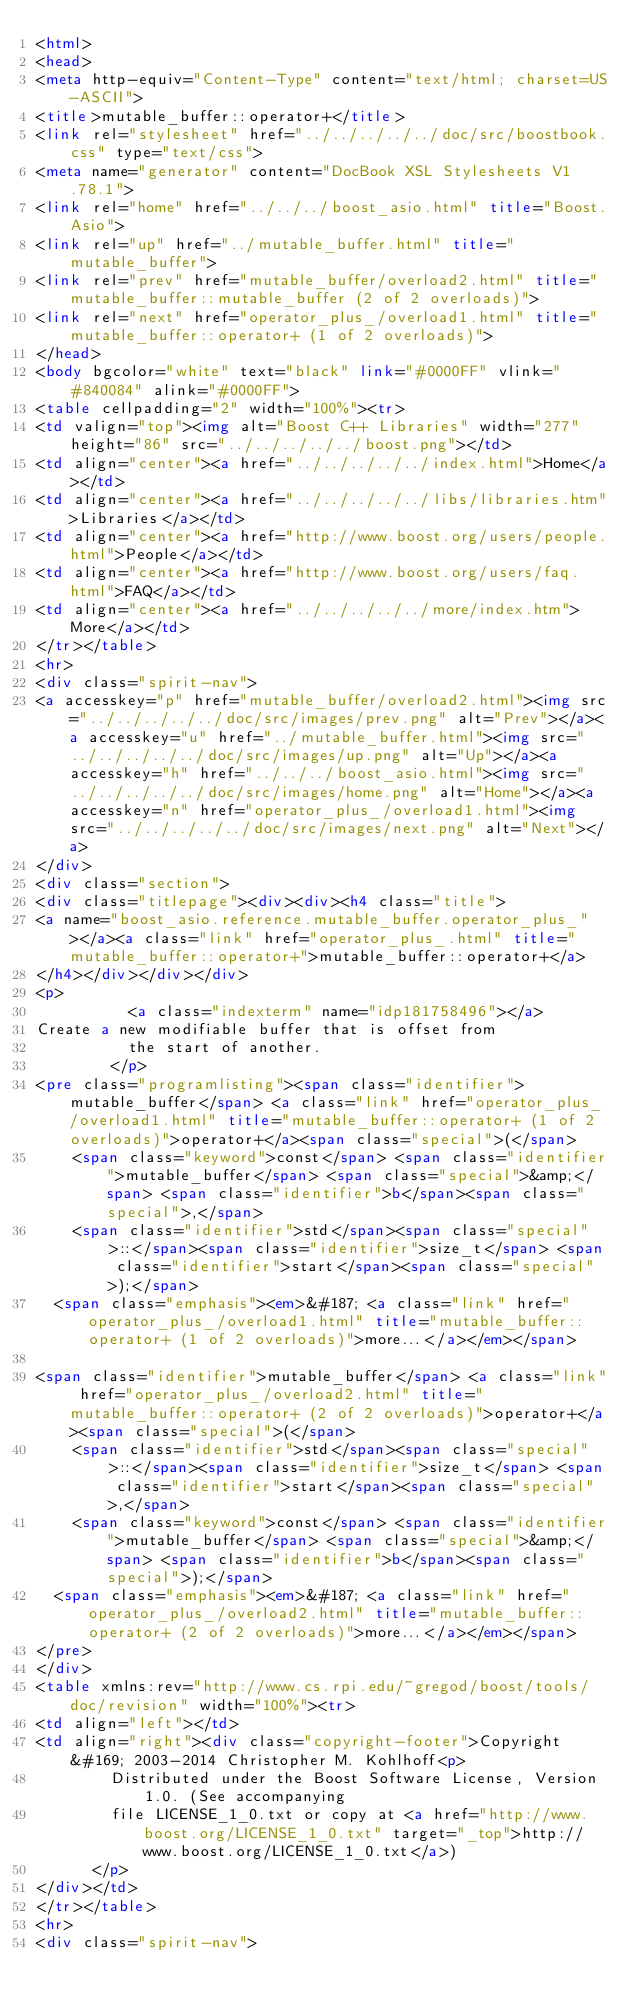Convert code to text. <code><loc_0><loc_0><loc_500><loc_500><_HTML_><html>
<head>
<meta http-equiv="Content-Type" content="text/html; charset=US-ASCII">
<title>mutable_buffer::operator+</title>
<link rel="stylesheet" href="../../../../../doc/src/boostbook.css" type="text/css">
<meta name="generator" content="DocBook XSL Stylesheets V1.78.1">
<link rel="home" href="../../../boost_asio.html" title="Boost.Asio">
<link rel="up" href="../mutable_buffer.html" title="mutable_buffer">
<link rel="prev" href="mutable_buffer/overload2.html" title="mutable_buffer::mutable_buffer (2 of 2 overloads)">
<link rel="next" href="operator_plus_/overload1.html" title="mutable_buffer::operator+ (1 of 2 overloads)">
</head>
<body bgcolor="white" text="black" link="#0000FF" vlink="#840084" alink="#0000FF">
<table cellpadding="2" width="100%"><tr>
<td valign="top"><img alt="Boost C++ Libraries" width="277" height="86" src="../../../../../boost.png"></td>
<td align="center"><a href="../../../../../index.html">Home</a></td>
<td align="center"><a href="../../../../../libs/libraries.htm">Libraries</a></td>
<td align="center"><a href="http://www.boost.org/users/people.html">People</a></td>
<td align="center"><a href="http://www.boost.org/users/faq.html">FAQ</a></td>
<td align="center"><a href="../../../../../more/index.htm">More</a></td>
</tr></table>
<hr>
<div class="spirit-nav">
<a accesskey="p" href="mutable_buffer/overload2.html"><img src="../../../../../doc/src/images/prev.png" alt="Prev"></a><a accesskey="u" href="../mutable_buffer.html"><img src="../../../../../doc/src/images/up.png" alt="Up"></a><a accesskey="h" href="../../../boost_asio.html"><img src="../../../../../doc/src/images/home.png" alt="Home"></a><a accesskey="n" href="operator_plus_/overload1.html"><img src="../../../../../doc/src/images/next.png" alt="Next"></a>
</div>
<div class="section">
<div class="titlepage"><div><div><h4 class="title">
<a name="boost_asio.reference.mutable_buffer.operator_plus_"></a><a class="link" href="operator_plus_.html" title="mutable_buffer::operator+">mutable_buffer::operator+</a>
</h4></div></div></div>
<p>
          <a class="indexterm" name="idp181758496"></a> 
Create a new modifiable buffer that is offset from
          the start of another.
        </p>
<pre class="programlisting"><span class="identifier">mutable_buffer</span> <a class="link" href="operator_plus_/overload1.html" title="mutable_buffer::operator+ (1 of 2 overloads)">operator+</a><span class="special">(</span>
    <span class="keyword">const</span> <span class="identifier">mutable_buffer</span> <span class="special">&amp;</span> <span class="identifier">b</span><span class="special">,</span>
    <span class="identifier">std</span><span class="special">::</span><span class="identifier">size_t</span> <span class="identifier">start</span><span class="special">);</span>
  <span class="emphasis"><em>&#187; <a class="link" href="operator_plus_/overload1.html" title="mutable_buffer::operator+ (1 of 2 overloads)">more...</a></em></span>

<span class="identifier">mutable_buffer</span> <a class="link" href="operator_plus_/overload2.html" title="mutable_buffer::operator+ (2 of 2 overloads)">operator+</a><span class="special">(</span>
    <span class="identifier">std</span><span class="special">::</span><span class="identifier">size_t</span> <span class="identifier">start</span><span class="special">,</span>
    <span class="keyword">const</span> <span class="identifier">mutable_buffer</span> <span class="special">&amp;</span> <span class="identifier">b</span><span class="special">);</span>
  <span class="emphasis"><em>&#187; <a class="link" href="operator_plus_/overload2.html" title="mutable_buffer::operator+ (2 of 2 overloads)">more...</a></em></span>
</pre>
</div>
<table xmlns:rev="http://www.cs.rpi.edu/~gregod/boost/tools/doc/revision" width="100%"><tr>
<td align="left"></td>
<td align="right"><div class="copyright-footer">Copyright &#169; 2003-2014 Christopher M. Kohlhoff<p>
        Distributed under the Boost Software License, Version 1.0. (See accompanying
        file LICENSE_1_0.txt or copy at <a href="http://www.boost.org/LICENSE_1_0.txt" target="_top">http://www.boost.org/LICENSE_1_0.txt</a>)
      </p>
</div></td>
</tr></table>
<hr>
<div class="spirit-nav"></code> 